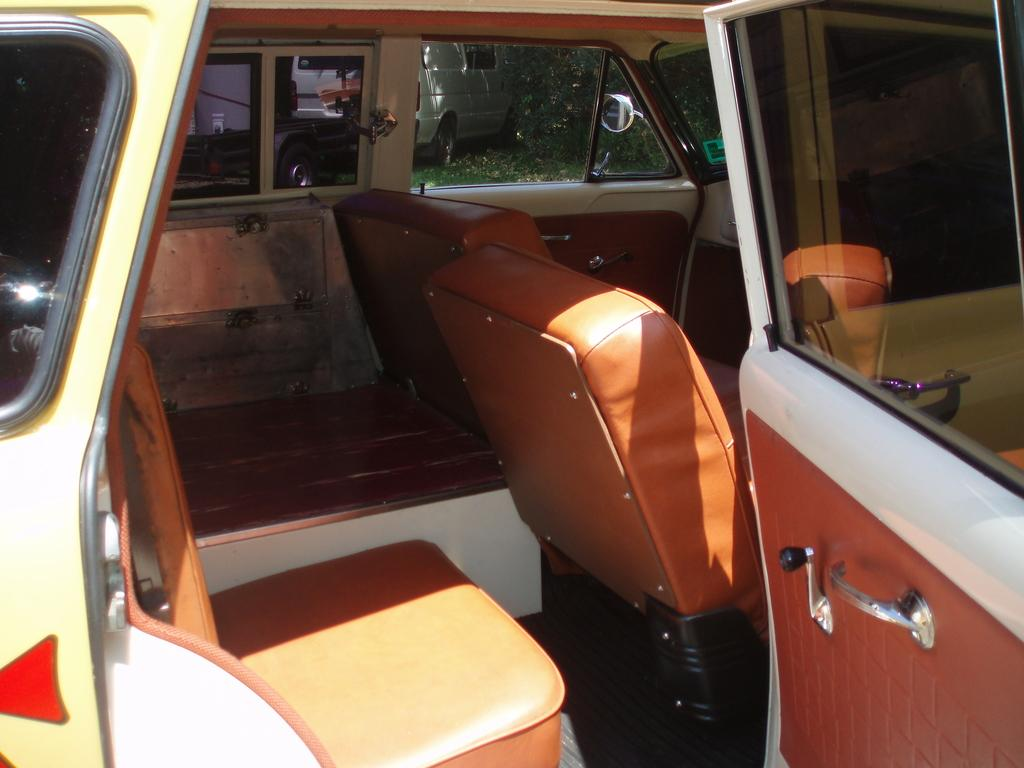What type of setting is depicted in the image? The image shows the inside of a vehicle. What can be seen outside the vehicle in the image? There is grass visible behind the vehicle. Are there any other vehicles present in the image? Yes, there is another vehicle in the image. What type of cast can be seen on the driver's arm in the image? There is no cast visible on anyone's arm in the image, as it only shows the inside of a vehicle and the surrounding grass. 